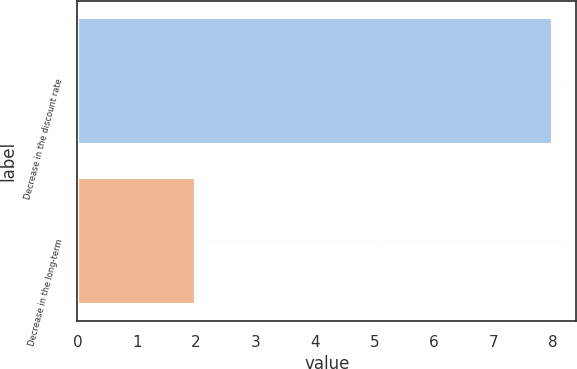Convert chart to OTSL. <chart><loc_0><loc_0><loc_500><loc_500><bar_chart><fcel>Decrease in the discount rate<fcel>Decrease in the long-term<nl><fcel>8<fcel>2<nl></chart> 